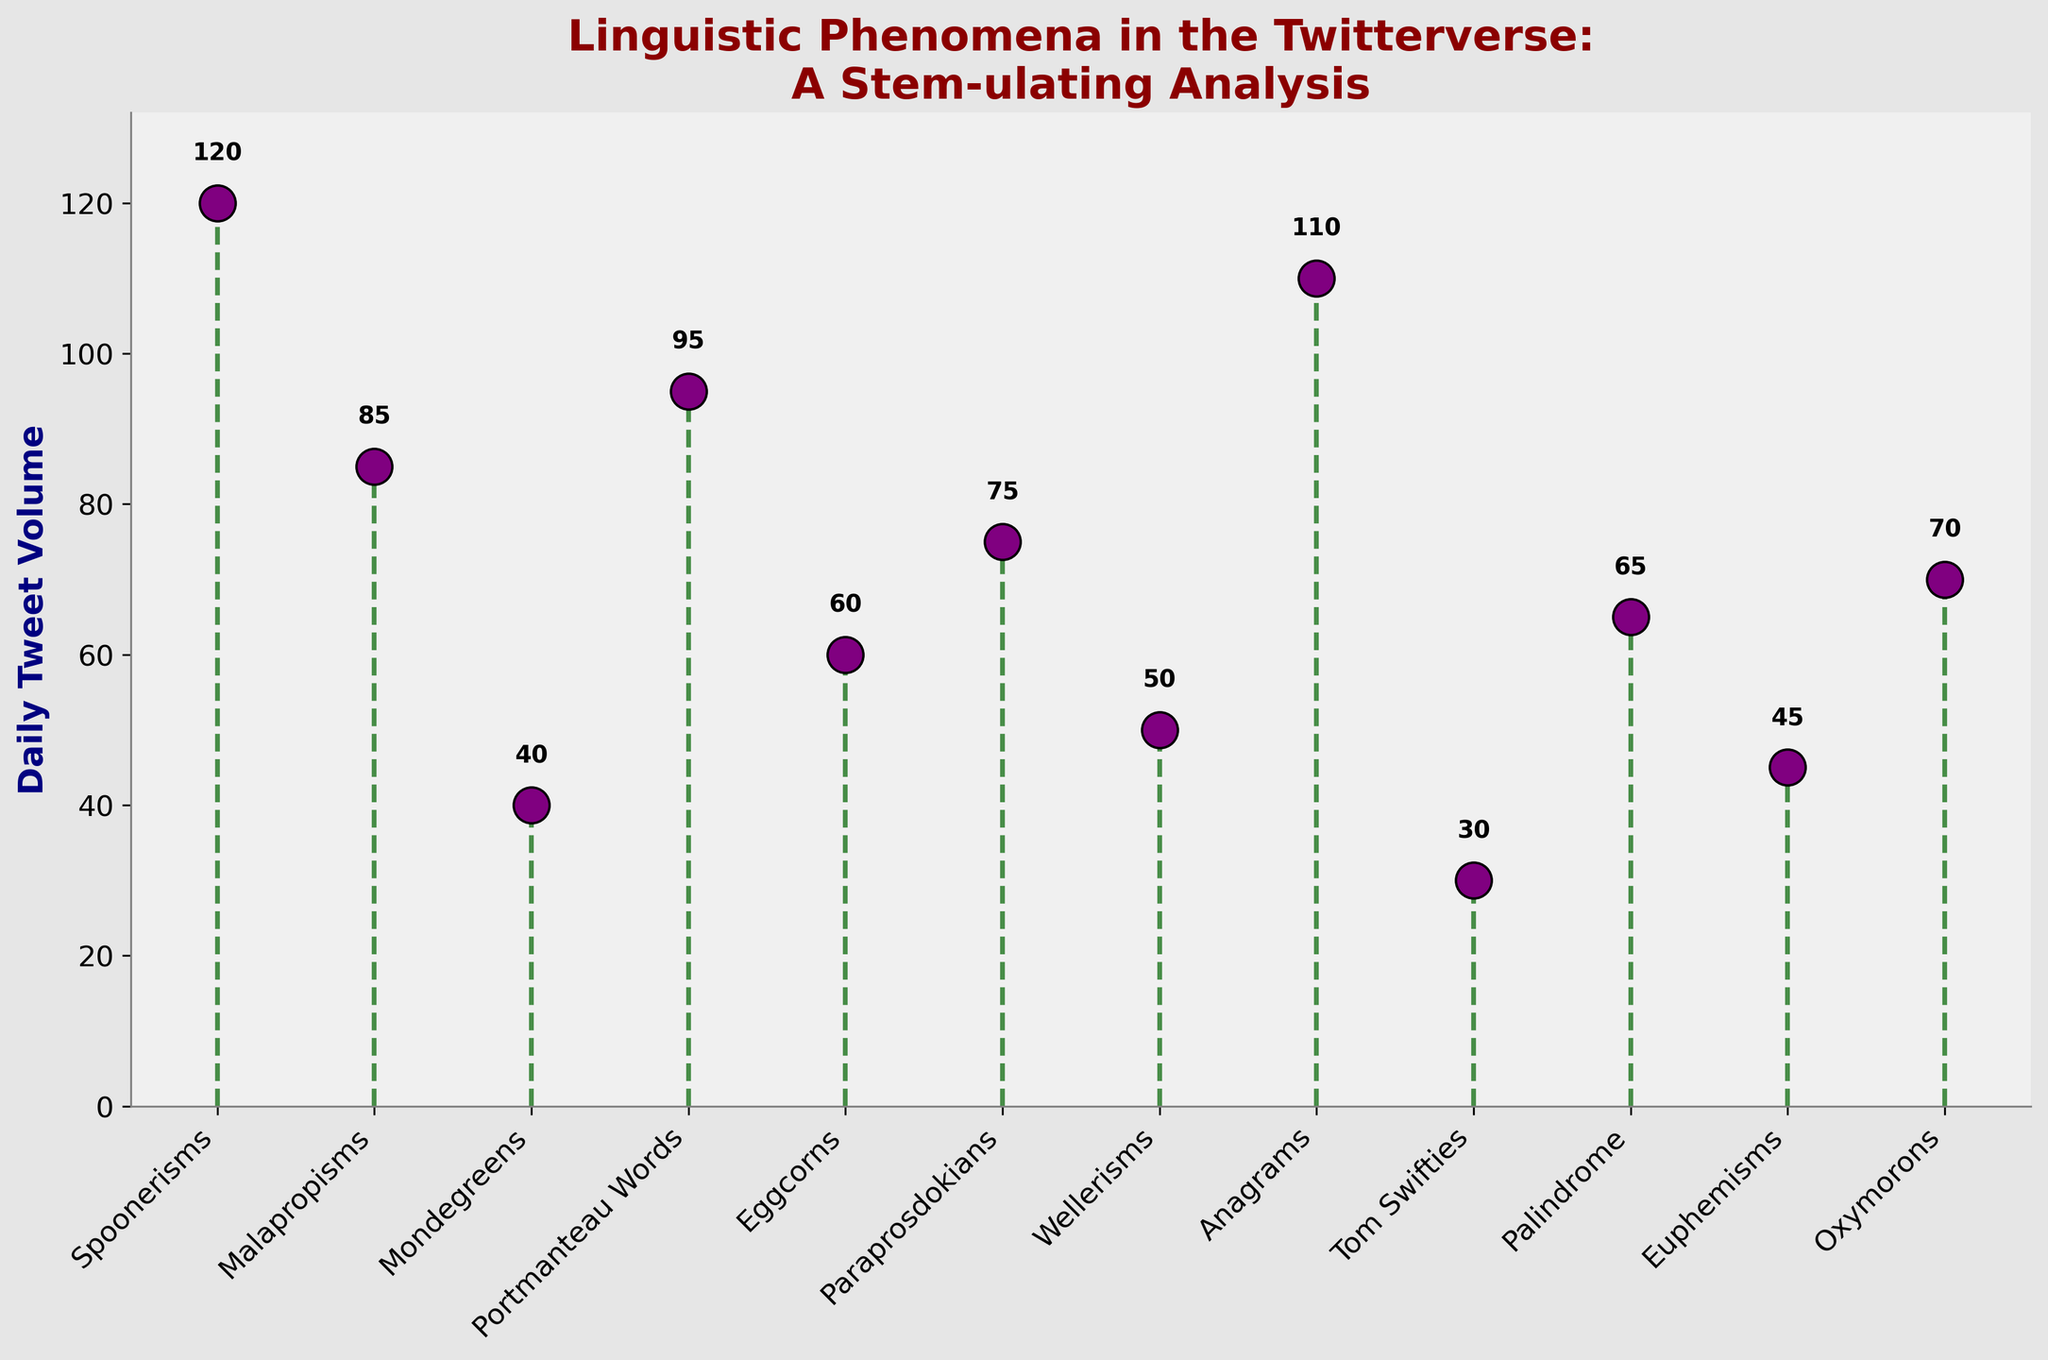what's the title of the figure? The title of a figure is typically displayed at the top of the figure, summarizing what the visual is about. Here, the title reads, "Linguistic Phenomena in the Twitterverse: A Stem-ulating Analysis"
Answer: Linguistic Phenomena in the Twitterverse: A Stem-ulating Analysis what does the y-axis of the figure represent? The label on the y-axis indicates what is being measured. In this figure, the y-axis is labeled "Daily Tweet Volume," which represents the number of tweets per day related to different linguistic phenomena.
Answer: Daily Tweet Volume how many linguistic phenomena are represented in the figure? Each unique marker on the x-axis corresponds to one linguistic phenomenon. By counting these markers or the labels along the x-axis, we see that there are 12 linguistic phenomena represented.
Answer: 12 which linguistic phenomenon has the highest daily tweet volume? By looking at the heights of the markers, the tallest marker indicates the highest volume. The phenomenon with the tallest marker is "Spoonerisms" at 120 tweets.
Answer: Spoonerisms what are the daily tweet volumes of "Malapropisms" and "Oxymorons"? Locate "Malapropisms" and "Oxymorons" on the x-axis and refer to their corresponding markers' heights. The volumes are labeled near the top of the marker: "Malapropisms" is 85, and "Oxymorons" is 70.
Answer: Malapropisms: 85, Oxymorons: 70 what is the difference in daily tweet volume between "Anagrams" and "Tom Swifties"? Identify the tweet volumes for "Anagrams" (110) and "Tom Swifties" (30). Subtract the smaller volume from the larger one: 110 - 30.
Answer: 80 what is the average daily tweet volume for "Spoonerisms," "Malapropisms," and "Mondegreens"? First, sum the volumes for "Spoonerisms" (120), "Malapropisms" (85), and "Mondegreens" (40): 120 + 85 + 40 = 245. Then, divide by the number of phenomena (3): 245 / 3.
Answer: 81.67 which phenomenon has a tweet volume closest to the average value of all listed phenomena? Calculate the average by summing all volumes: 120 + 85 + 40 + 95 + 60 + 75 + 50 + 110 + 30 + 65 + 45 + 70 = 845. Divide by 12 to get the average: 845 / 12 ≈ 70.42. Compare each volume to find the closest to this average, which is "Oxymorons" with a volume of 70.
Answer: Oxymorons how does the daily tweet volume of "Palindrome" compare to "Euphemisms"? Locate both phenomena on the x-axis and compare their volumes. "Palindrome" has a volume of 65, and "Euphemisms" has a volume of 45. "Palindrome" has a higher volume than "Euphemisms."
Answer: Palindrome is higher which four phenomena have the lowest daily tweet volumes? Identify the lowest markers: "Tom Swifties" (30), "Mondegreens" (40), "Euphemisms" (45), and "Wellerisms" (50), based on the heights of the markers.
Answer: Tom Swifties, Mondegreens, Euphemisms, Wellerisms 